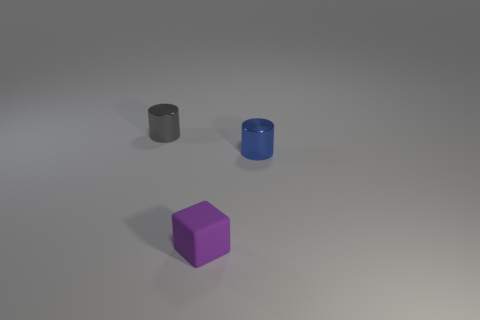Is there anything else that has the same material as the small purple object?
Your answer should be compact. No. There is a gray cylinder that is the same material as the small blue cylinder; what is its size?
Offer a very short reply. Small. Does the rubber object have the same color as the metallic thing on the left side of the purple rubber object?
Provide a short and direct response. No. The small object that is both on the left side of the blue thing and behind the block is made of what material?
Your answer should be compact. Metal. There is a object that is to the right of the block; does it have the same shape as the small metallic object behind the blue shiny thing?
Your response must be concise. Yes. Is there a small gray rubber cylinder?
Offer a terse response. No. What color is the other metallic object that is the same shape as the tiny gray metal object?
Your answer should be compact. Blue. The other cylinder that is the same size as the blue shiny cylinder is what color?
Give a very brief answer. Gray. Is the small blue cylinder made of the same material as the tiny gray cylinder?
Offer a terse response. Yes. How many cylinders have the same color as the matte block?
Ensure brevity in your answer.  0. 